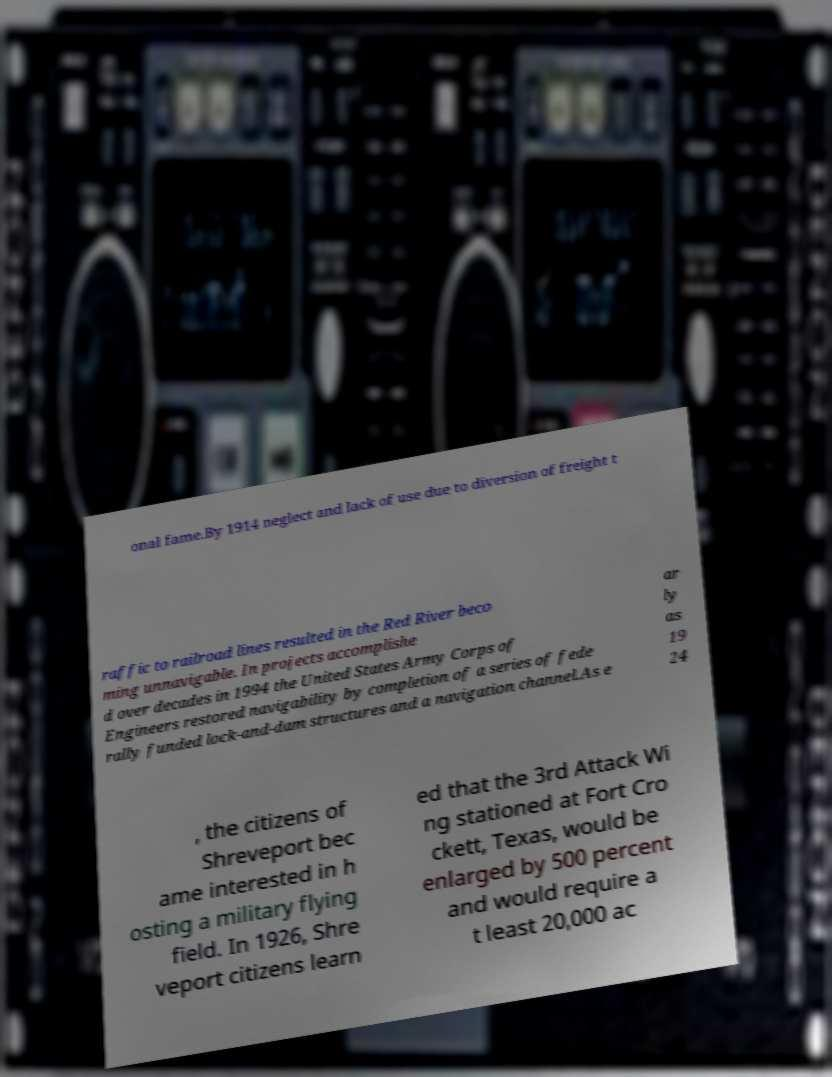Can you accurately transcribe the text from the provided image for me? onal fame.By 1914 neglect and lack of use due to diversion of freight t raffic to railroad lines resulted in the Red River beco ming unnavigable. In projects accomplishe d over decades in 1994 the United States Army Corps of Engineers restored navigability by completion of a series of fede rally funded lock-and-dam structures and a navigation channel.As e ar ly as 19 24 , the citizens of Shreveport bec ame interested in h osting a military flying field. In 1926, Shre veport citizens learn ed that the 3rd Attack Wi ng stationed at Fort Cro ckett, Texas, would be enlarged by 500 percent and would require a t least 20,000 ac 